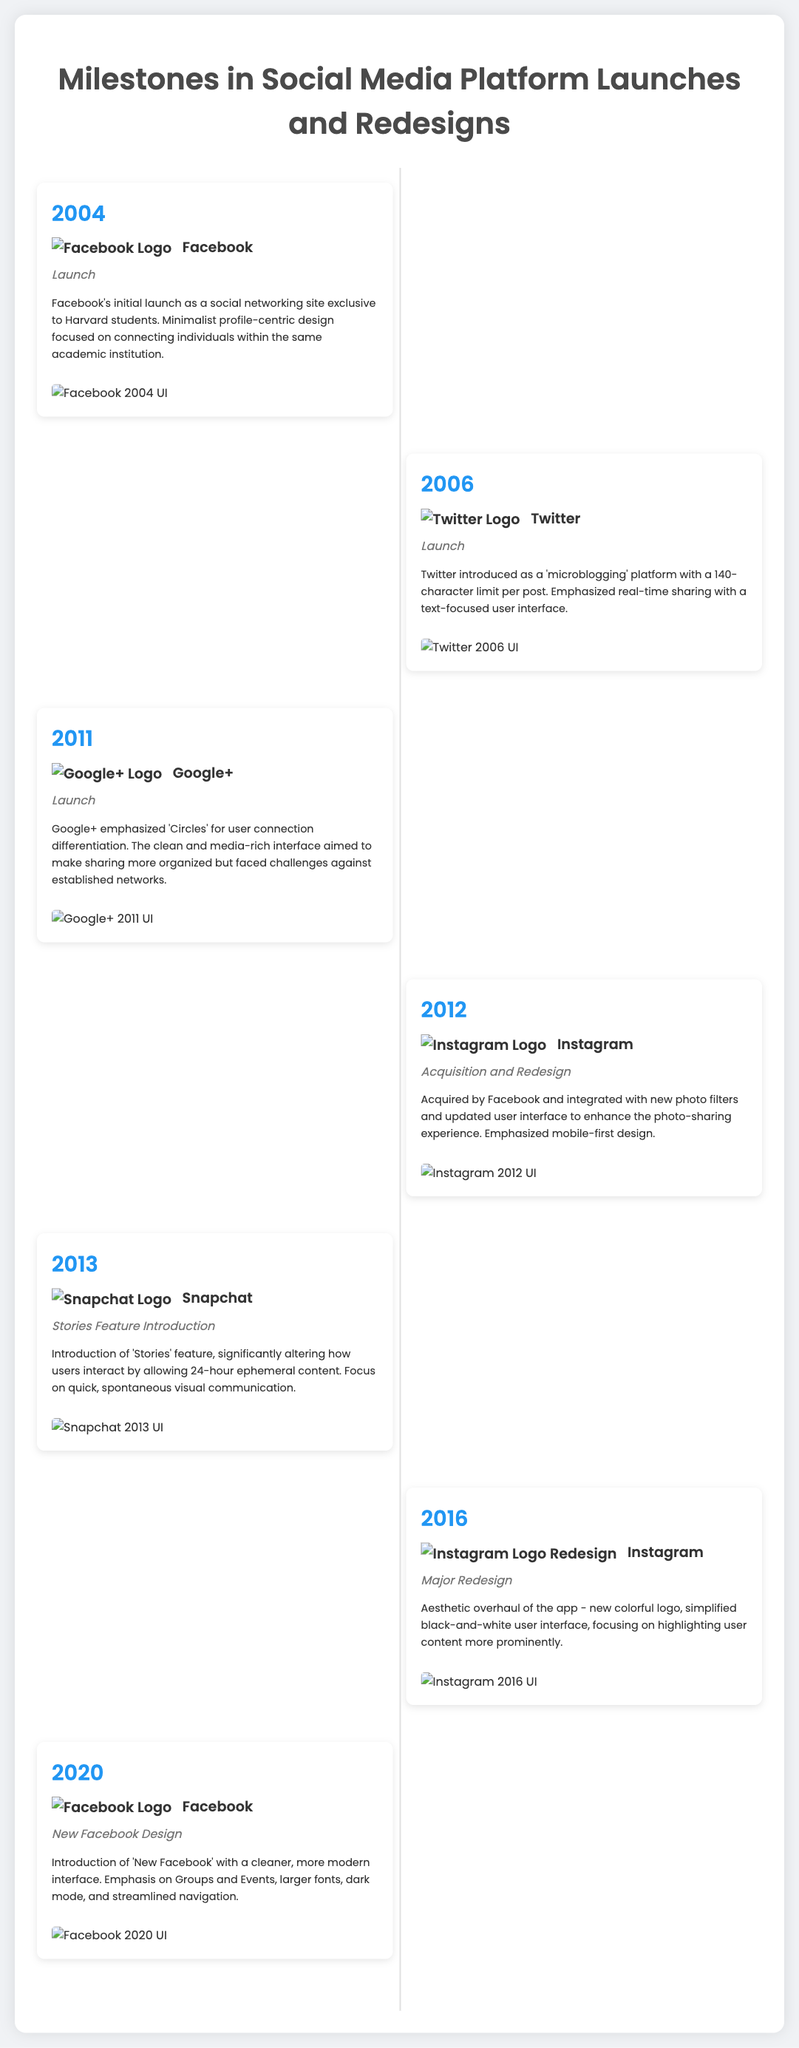What year was Facebook launched? Facebook was launched in 2004, as indicated in the timeline entry.
Answer: 2004 What is the primary feature introduced by Snapchat in 2013? The primary feature introduced by Snapchat in 2013 was the 'Stories' feature, which is mentioned in the description.
Answer: Stories Which platform underwent a major redesign in 2016? The timeline indicates that Instagram underwent a major redesign in 2016, focusing on a new aesthetic and user interface changes.
Answer: Instagram What was the focus of Twitter's user interface when it was launched? Twitter's user interface emphasized real-time sharing with a text-focused design, as stated in the description.
Answer: Text-focused What notable change did Facebook introduce in 2020? Facebook introduced a new design with a cleaner, modern interface, which is described in the timeline entry.
Answer: New Facebook design How many years passed between Facebook's launch and Instagram's acquisition in 2012? Facebook was launched in 2004 and Instagram was acquired in 2012, making it an 8-year gap.
Answer: 8 years What type of design did Google+ emphasize upon its launch? Google+ emphasized 'Circles' for connecting users differently, highlighted in the event description.
Answer: Circles What distinguishes the 2016 Instagram redesign from its previous versions? The 2016 redesign featured a new colorful logo and a simplified user interface, as detailed in the entry.
Answer: Colorful logo Which social media platform launched as a microblogging service? Twitter was introduced as a microblogging platform in 2006, as per the event description.
Answer: Twitter 